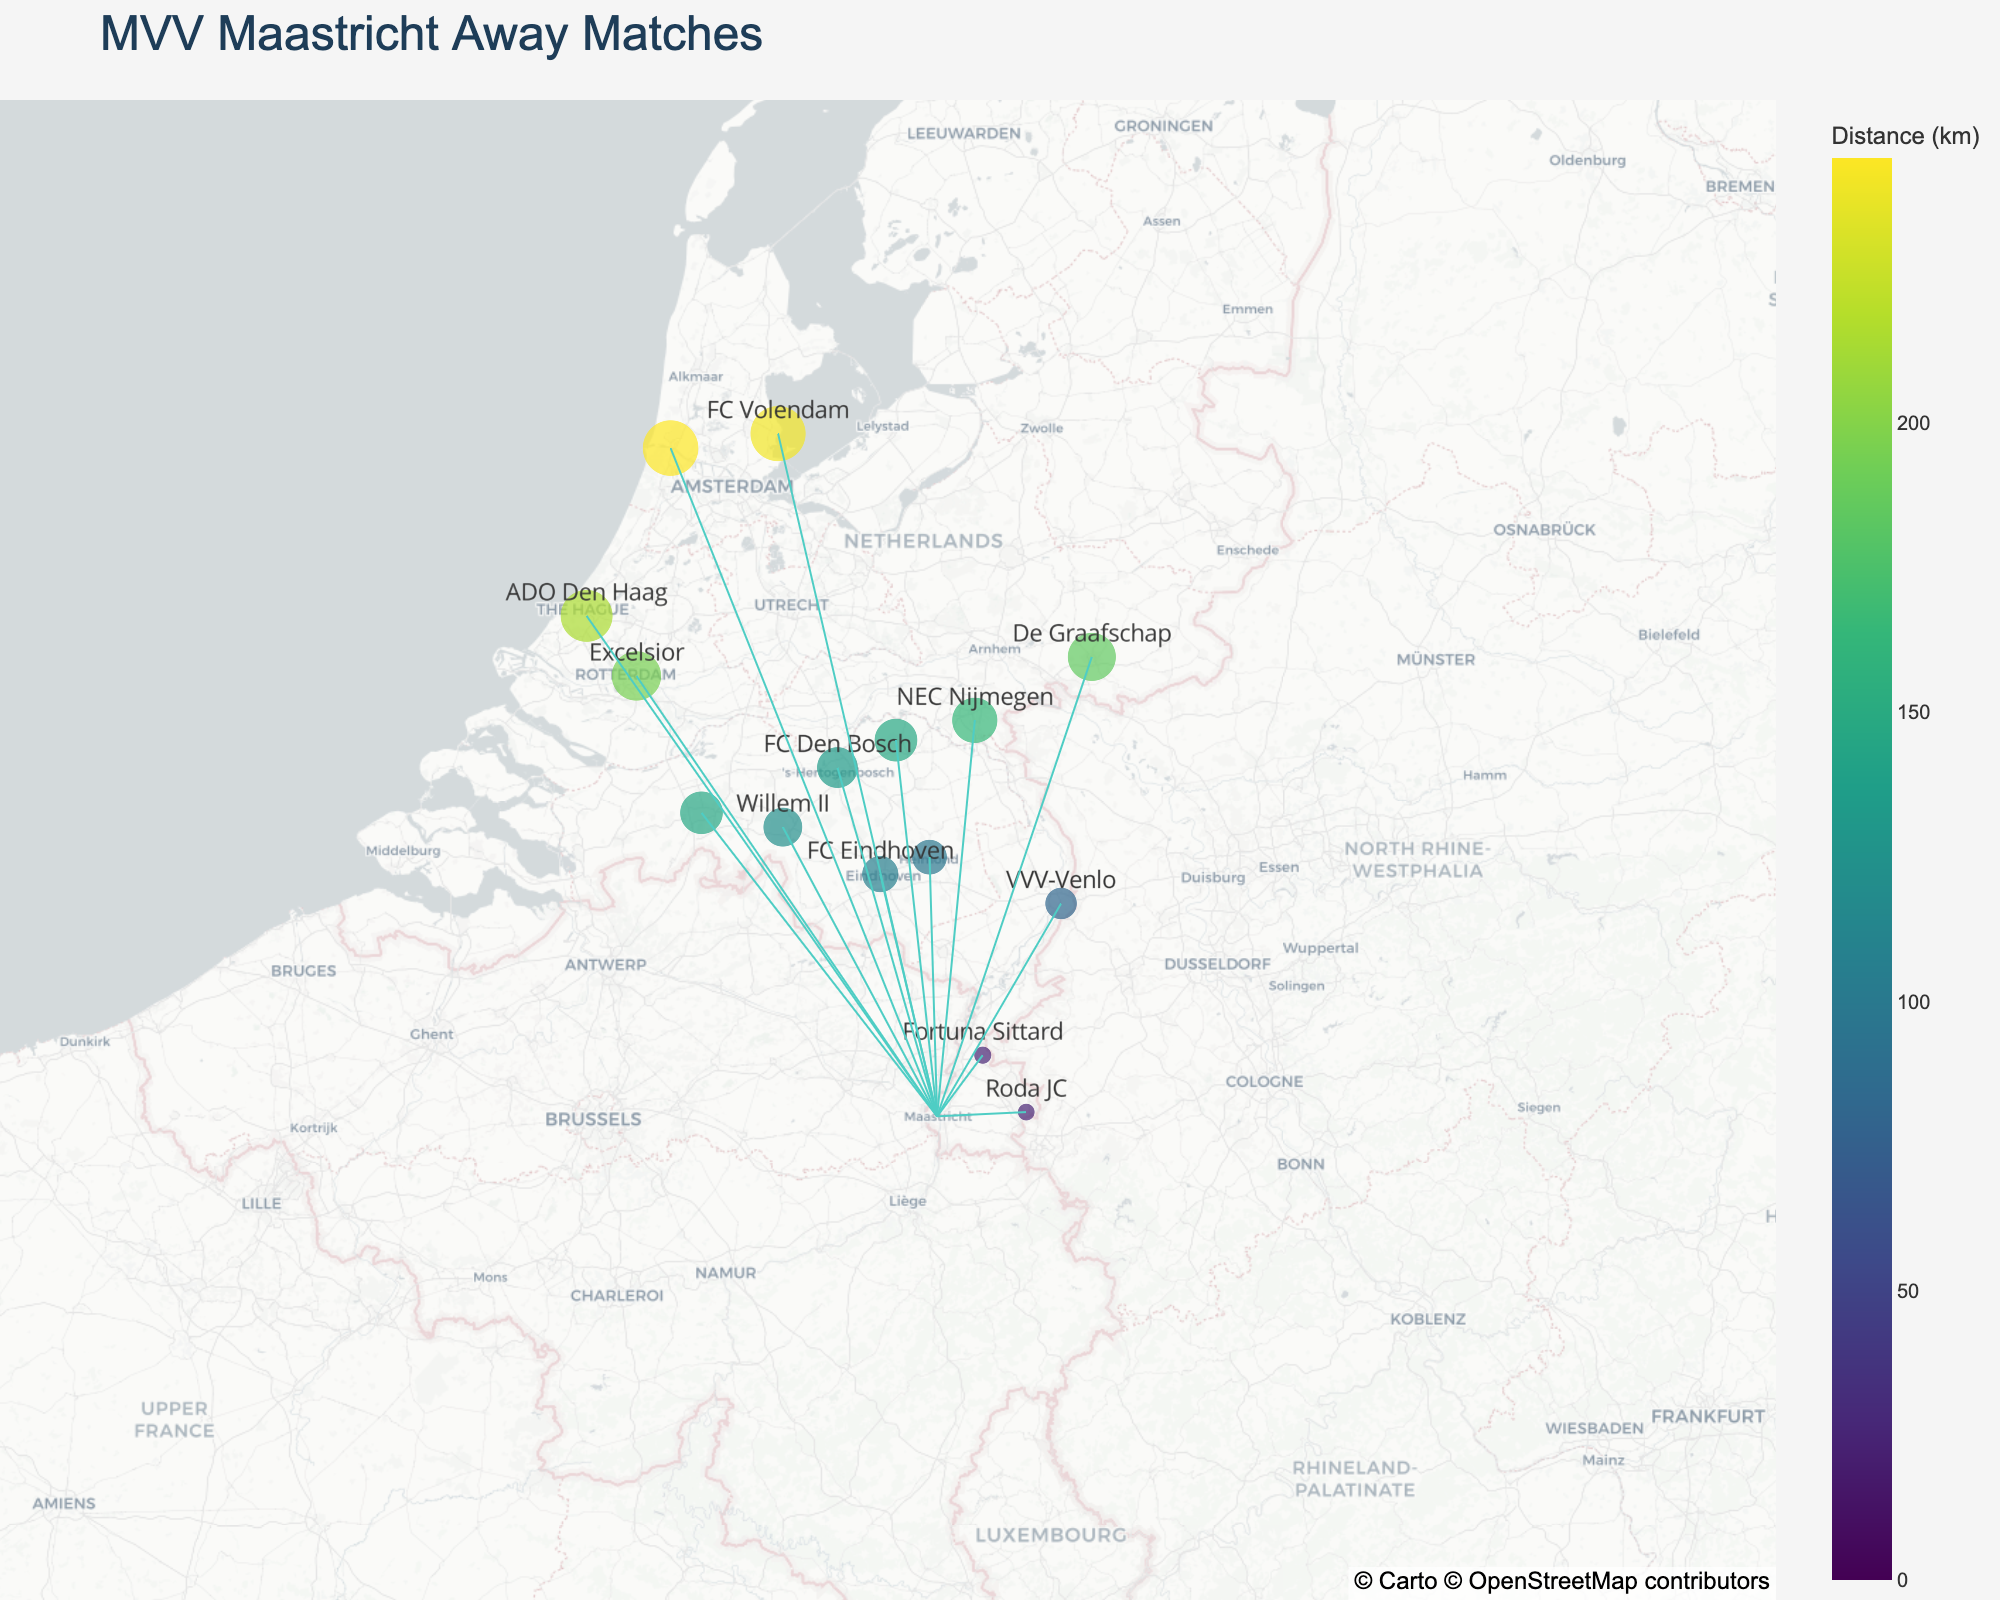What is the title of the plot? The title is usually displayed at the top of the plot. It is used to provide a summary description of what the plot represents.
Answer: MVV Maastricht Away Matches Which team is the closest to MVV Maastricht? The closest team will be the one with the smallest distance from Maastricht. This can be seen by locating the point nearest to Maastricht on the map or checking the distance values.
Answer: Roda JC How many teams have a distance from Maastricht greater than 100 km? Look at the distances provided for each team and count how many of those are greater than 100 km.
Answer: 11 Which team has the farthest travel distance from Maastricht? Identify the team with the largest distance from Maastricht by checking the values on the map or the distance data.
Answer: Telstar What is the average distance of MVV Maastricht's away matches? Sum all the distances provided for each team and divide by the number of teams to get the average.
Answer: (0 + 24 + 25 + 81 + 98 + 106 + 146 + 122 + 134 + 147 + 185 + 164 + 246 + 242 + 215 + 195) / 16 = 135.125 Compare the travel distance to Venlo (VVV-Venlo) and Tilburg (Willem II). Which one is farther? Check the distances provided for Venlo and Tilburg and compare them. Venlo is 81 km away, and Tilburg is 122 km away; hence, Tilburg is farther.
Answer: Tilburg How many lines are there connecting MVV Maastricht to other teams? Each line represents a connection from Maastricht to another team. Count the number of lines originating from Maastricht.
Answer: 15 Which team near Maastricht has a distance almost equal to Helmond Sport? Identify the distance of Helmond Sport (98 km) and check for other teams with similar distances. FC Eindhoven is very close with a distance of 106 km.
Answer: FC Eindhoven What are the coordinates of MVV Maastricht? Look for the coordinates specified for MVV Maastricht on the map. Typically, these are provided as latitude and longitude values.
Answer: 50.8514, 5.6910 Which team is represented by a marker at approximately (52.4614, 4.6553)? Match the coordinates given to the team listed in the data. The coordinates (52.4614, 4.6553) correspond to Telstar.
Answer: Telstar 